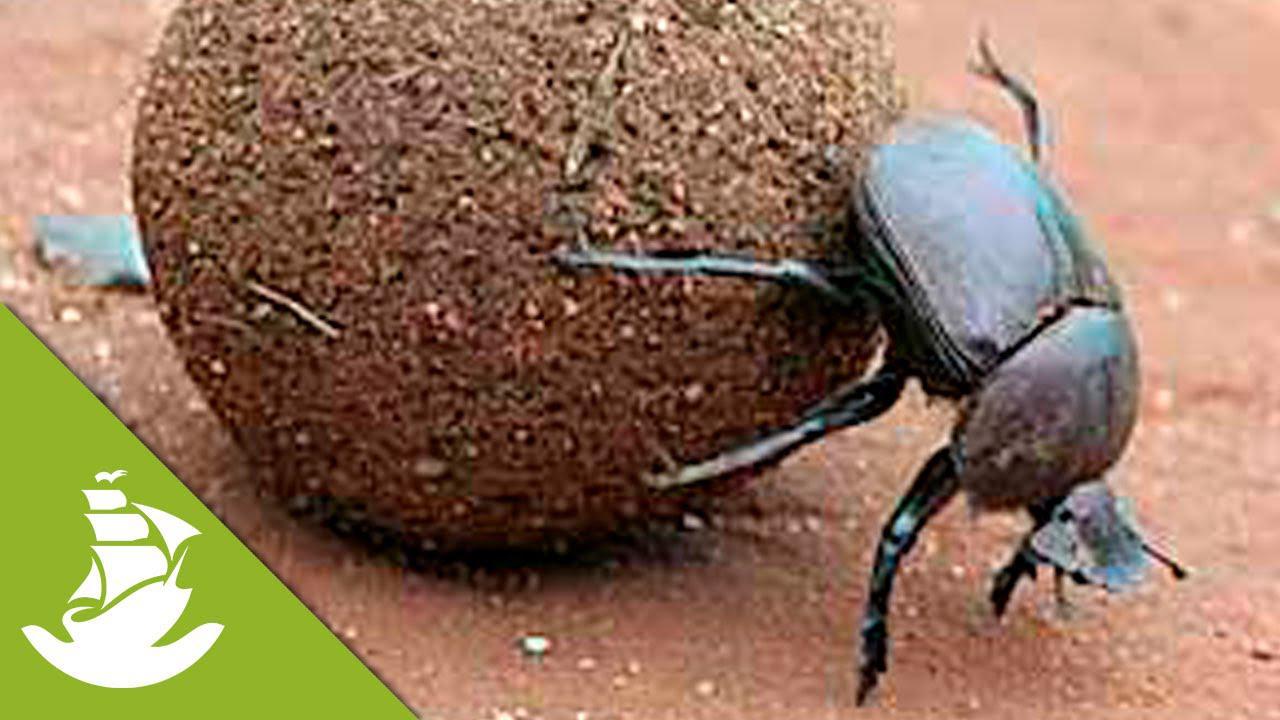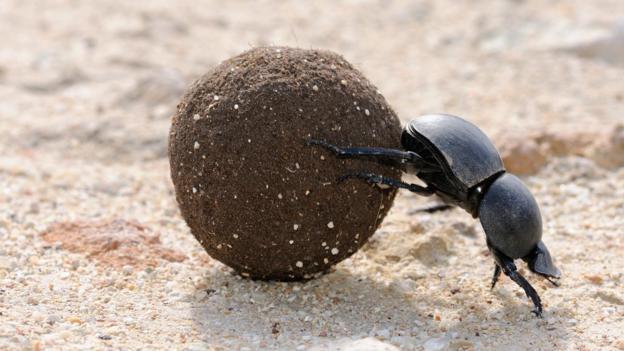The first image is the image on the left, the second image is the image on the right. Analyze the images presented: Is the assertion "An image shows a beetle atop a dung ball, so its body is parallel with the ground." valid? Answer yes or no. No. The first image is the image on the left, the second image is the image on the right. Assess this claim about the two images: "At least one beatle has its hind legs on a ball while its front legs are on the ground.". Correct or not? Answer yes or no. Yes. 